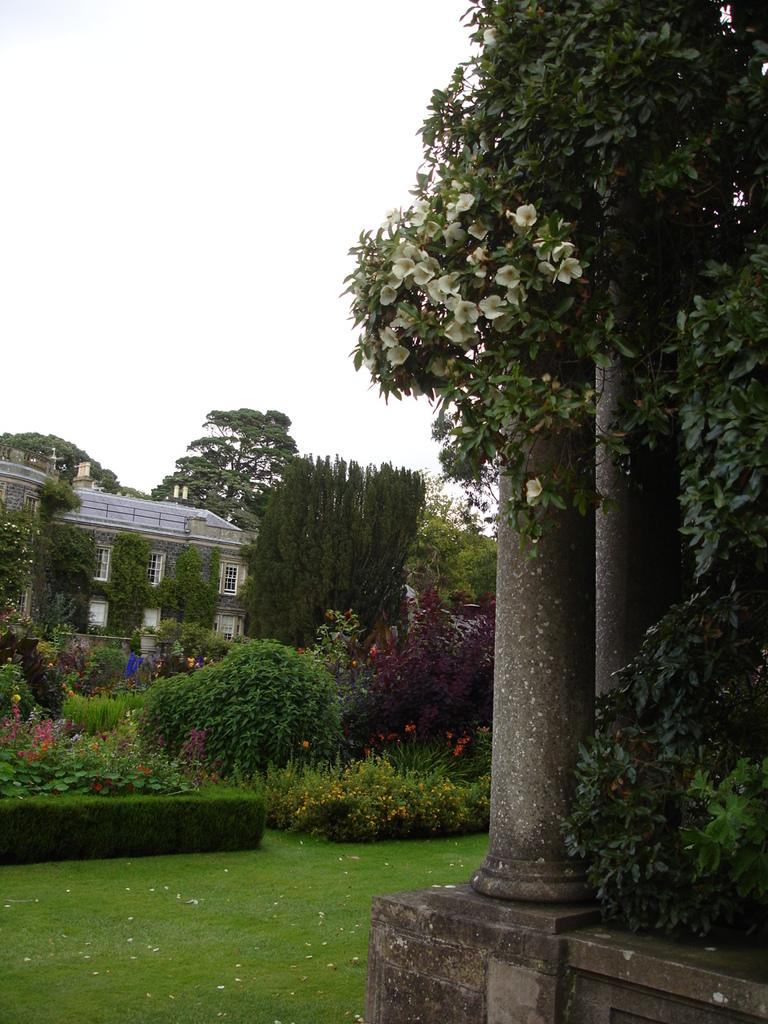What natural element is visible in the image? The sky is visible in the image. What type of weather can be inferred from the image? Clouds are present in the image, suggesting a partly cloudy or overcast day. What type of vegetation is visible in the image? Trees, plants, and grass are visible in the image. What architectural features are present in the image? Pillars and at least one building are present in the image. How many cakes are being compared in the image? There are no cakes present in the image, so it is not possible to compare any cakes. 